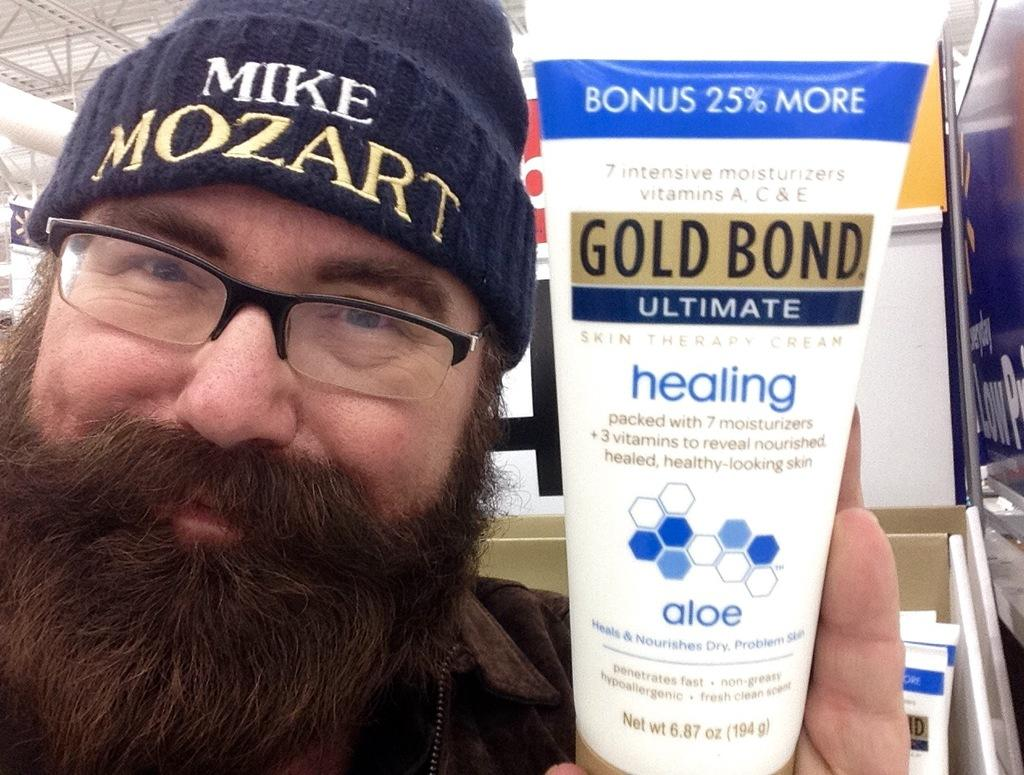<image>
Summarize the visual content of the image. A man wearing a hat that says Mike Mozart is holding a tube of Gold Bond Ultimate Healing lotion. 